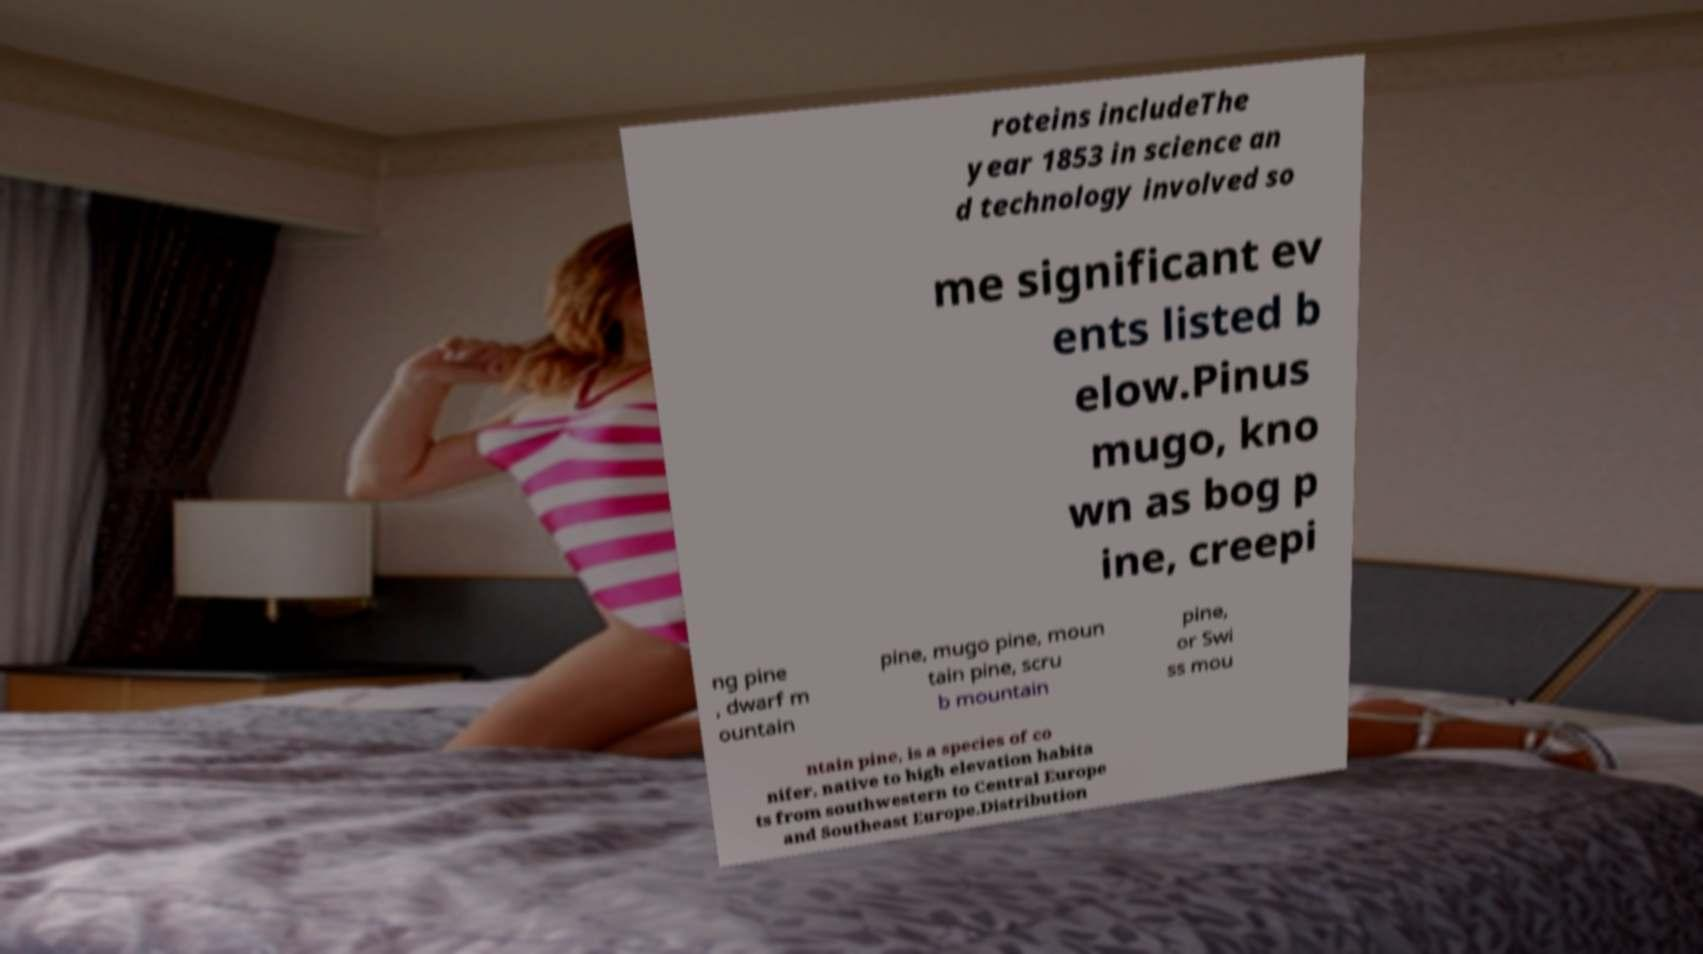Can you accurately transcribe the text from the provided image for me? roteins includeThe year 1853 in science an d technology involved so me significant ev ents listed b elow.Pinus mugo, kno wn as bog p ine, creepi ng pine , dwarf m ountain pine, mugo pine, moun tain pine, scru b mountain pine, or Swi ss mou ntain pine, is a species of co nifer, native to high elevation habita ts from southwestern to Central Europe and Southeast Europe.Distribution 